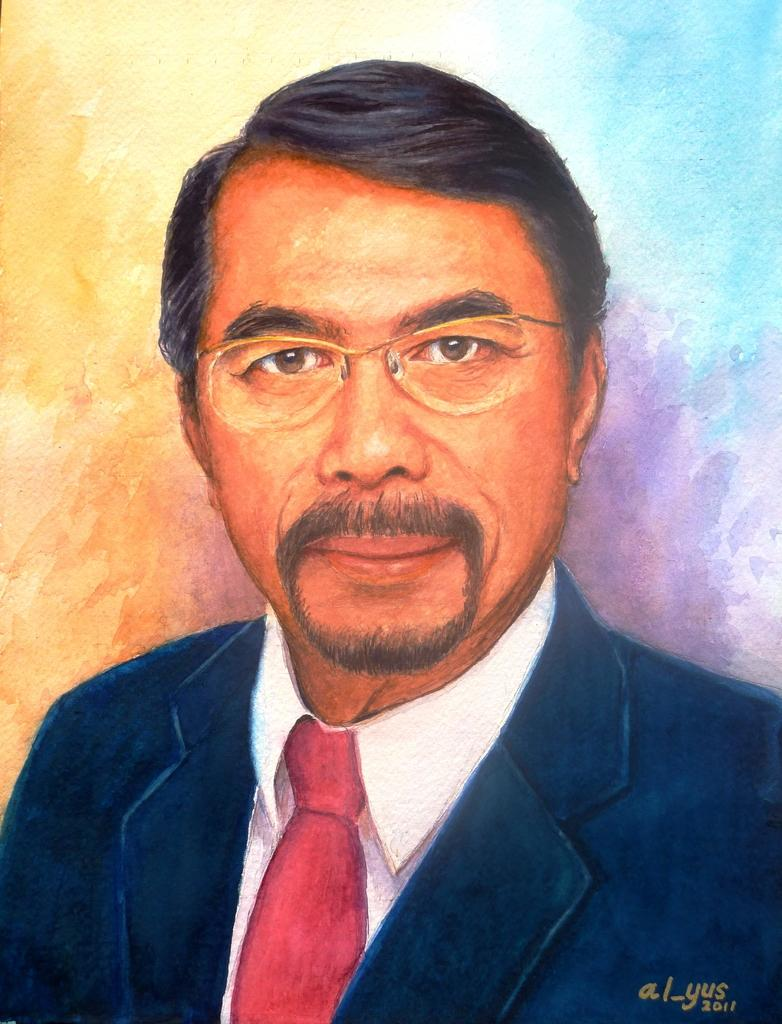What is the main subject of the image? The image contains a painting. What is the painting depicting? The painting depicts a man. Can you describe the man's attire in the painting? The man is wearing a blazer, a shirt, and a tie. He is also wearing spectacles. What can be observed about the background of the painting? The background of the painting is colorful. How many bananas are being used as currency in the painting? There are no bananas present in the painting, nor are they being used as currency. 